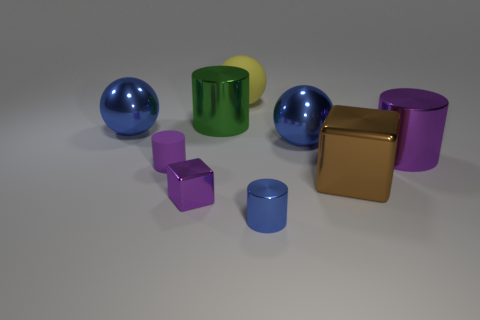Is there a metal cylinder that has the same color as the small rubber cylinder?
Your response must be concise. Yes. There is a purple shiny thing that is the same size as the yellow matte sphere; what shape is it?
Keep it short and to the point. Cylinder. There is a metal cylinder on the right side of the small blue metal object; what is its color?
Keep it short and to the point. Purple. Is there a cylinder that is behind the blue sphere that is left of the tiny purple cylinder?
Your answer should be compact. Yes. What number of things are small objects that are to the right of the yellow matte ball or tiny brown spheres?
Provide a succinct answer. 1. Are there any other things that have the same size as the brown metal thing?
Offer a terse response. Yes. What material is the block on the left side of the tiny cylinder in front of the purple shiny block made of?
Your answer should be compact. Metal. Are there an equal number of large metallic cylinders left of the big brown metallic thing and big objects that are to the left of the small shiny cylinder?
Ensure brevity in your answer.  No. How many objects are brown metal cubes to the right of the tiny rubber cylinder or small purple things that are in front of the large block?
Offer a very short reply. 2. The ball that is on the right side of the big green metallic object and in front of the big yellow rubber object is made of what material?
Provide a short and direct response. Metal. 